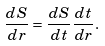<formula> <loc_0><loc_0><loc_500><loc_500>\frac { d S } { d r } = \frac { d S } { d t } \frac { d t } { d r } .</formula> 